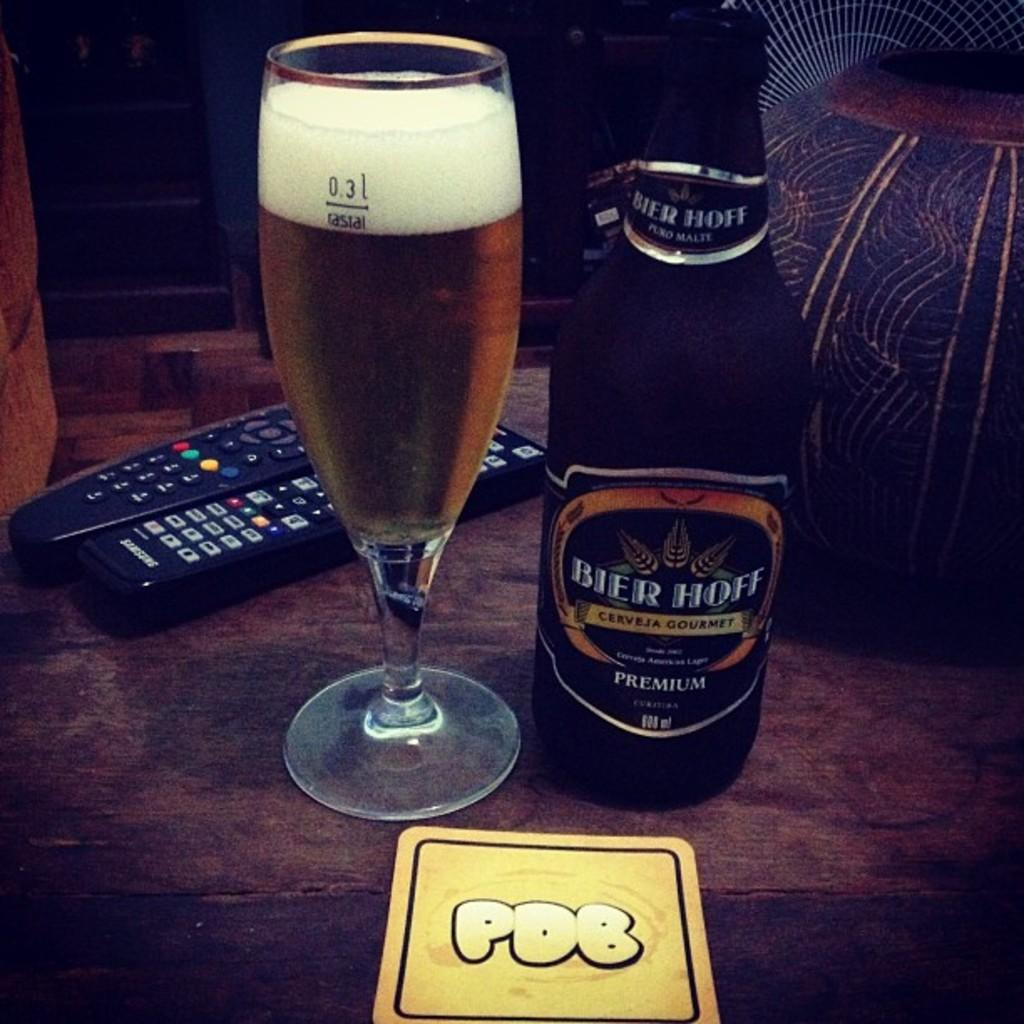What type of bottle is visible in the image? There is a beer bottle in the image. What else can be seen on the table in the image? There is a glass in the image, and the glass contains a drink. How many remotes are present in the image? There are two remotes in the image. Where are all the items located in the image? All the items are placed on a table. What type of pest can be seen crawling on the glass in the image? There are no pests visible in the image; it only features a beer bottle, a glass with a drink, two remotes, and a table. 